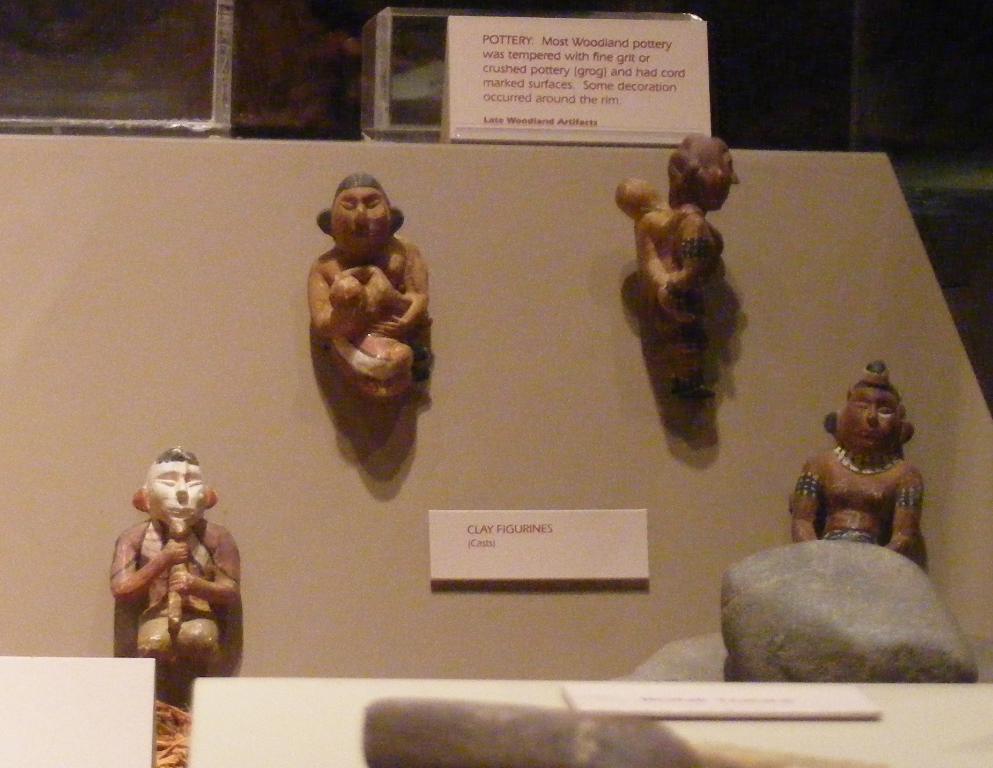How would you summarize this image in a sentence or two? In this picture we can see statue of the persons. On the top there is a poster. Here we can see a nameplate which is near to the stones. On the top background we can see the racks. 